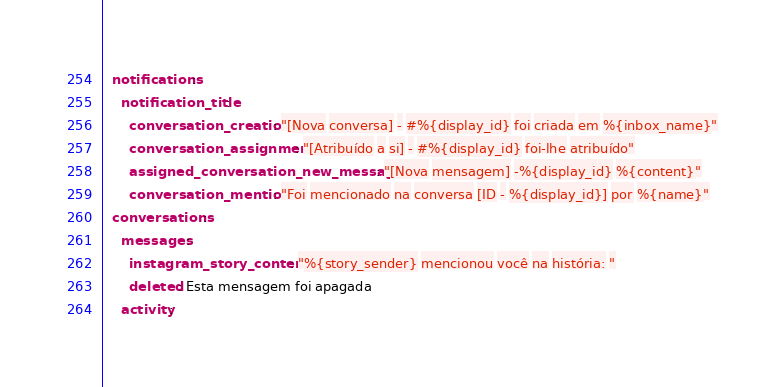<code> <loc_0><loc_0><loc_500><loc_500><_YAML_>  notifications:
    notification_title:
      conversation_creation: "[Nova conversa] - #%{display_id} foi criada em %{inbox_name}"
      conversation_assignment: "[Atribuído a si] - #%{display_id} foi-lhe atribuído"
      assigned_conversation_new_message: "[Nova mensagem] -%{display_id} %{content}"
      conversation_mention: "Foi mencionado na conversa [ID - %{display_id}] por %{name}"
  conversations:
    messages:
      instagram_story_content: "%{story_sender} mencionou você na história: "
      deleted: Esta mensagem foi apagada
    activity:</code> 